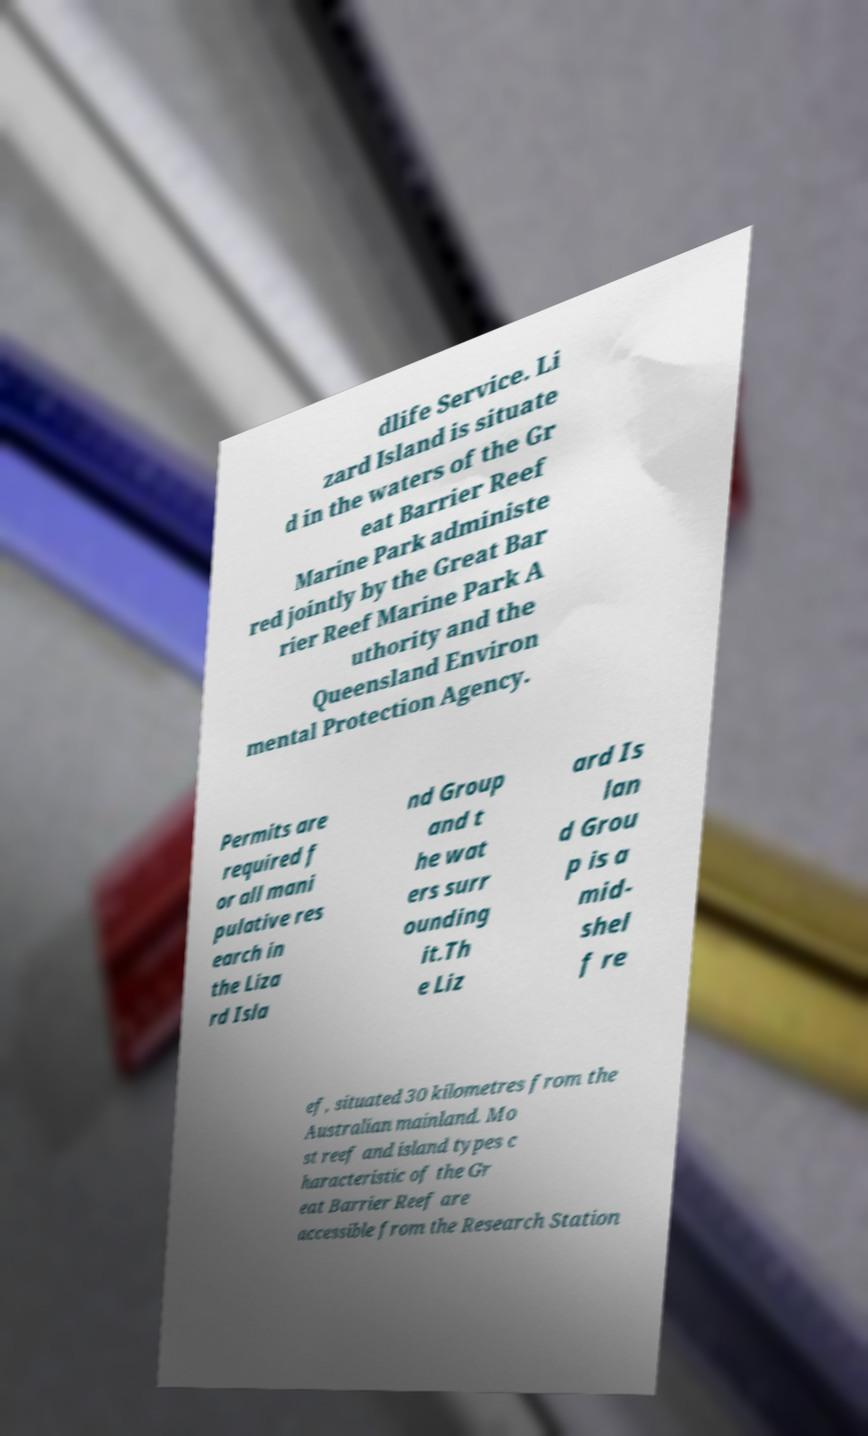Can you read and provide the text displayed in the image?This photo seems to have some interesting text. Can you extract and type it out for me? dlife Service. Li zard Island is situate d in the waters of the Gr eat Barrier Reef Marine Park administe red jointly by the Great Bar rier Reef Marine Park A uthority and the Queensland Environ mental Protection Agency. Permits are required f or all mani pulative res earch in the Liza rd Isla nd Group and t he wat ers surr ounding it.Th e Liz ard Is lan d Grou p is a mid- shel f re ef, situated 30 kilometres from the Australian mainland. Mo st reef and island types c haracteristic of the Gr eat Barrier Reef are accessible from the Research Station 